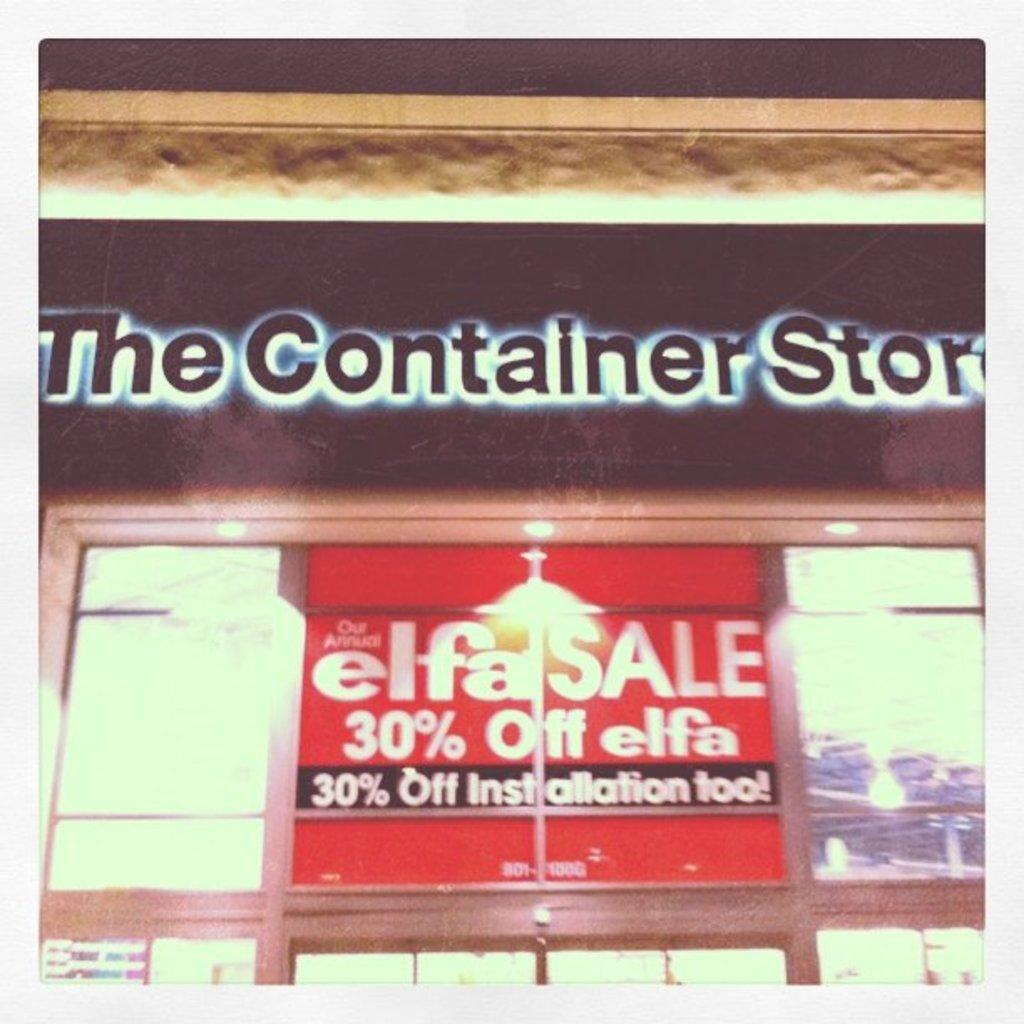<image>
Give a short and clear explanation of the subsequent image. the word container is on the front of the store 